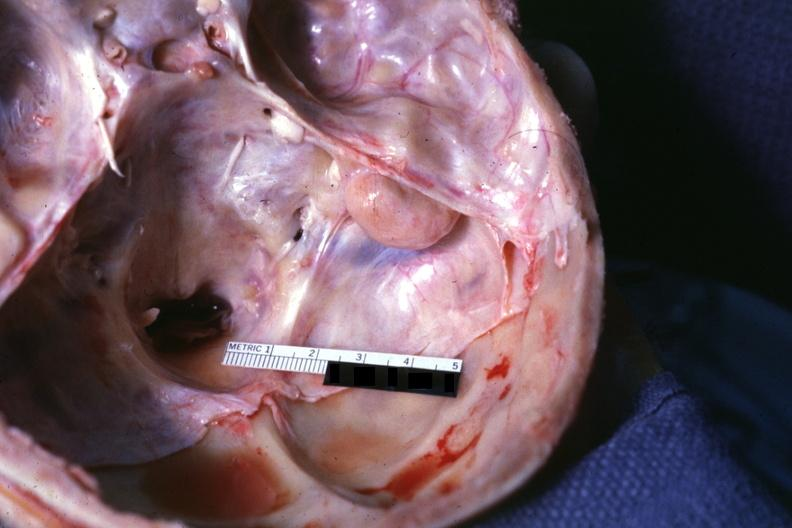what is present?
Answer the question using a single word or phrase. Fibrous meningioma 